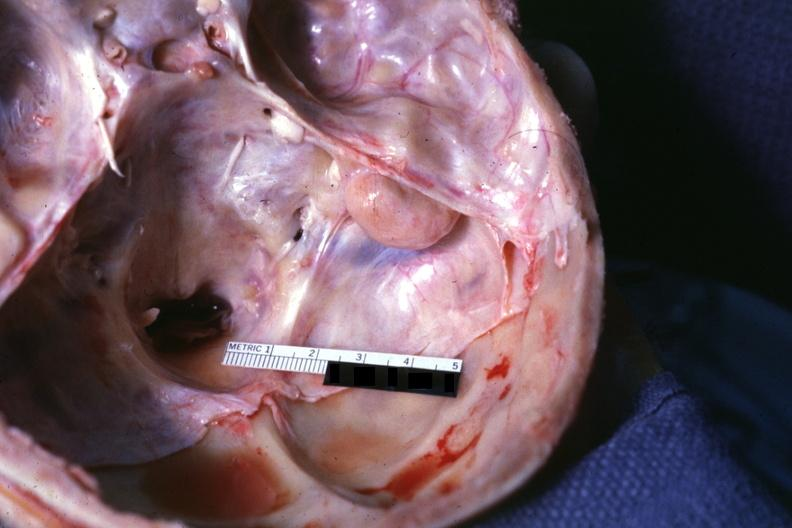what is present?
Answer the question using a single word or phrase. Fibrous meningioma 